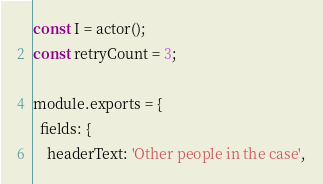Convert code to text. <code><loc_0><loc_0><loc_500><loc_500><_JavaScript_>const I = actor();
const retryCount = 3;

module.exports = {
  fields: {
    headerText: 'Other people in the case',</code> 